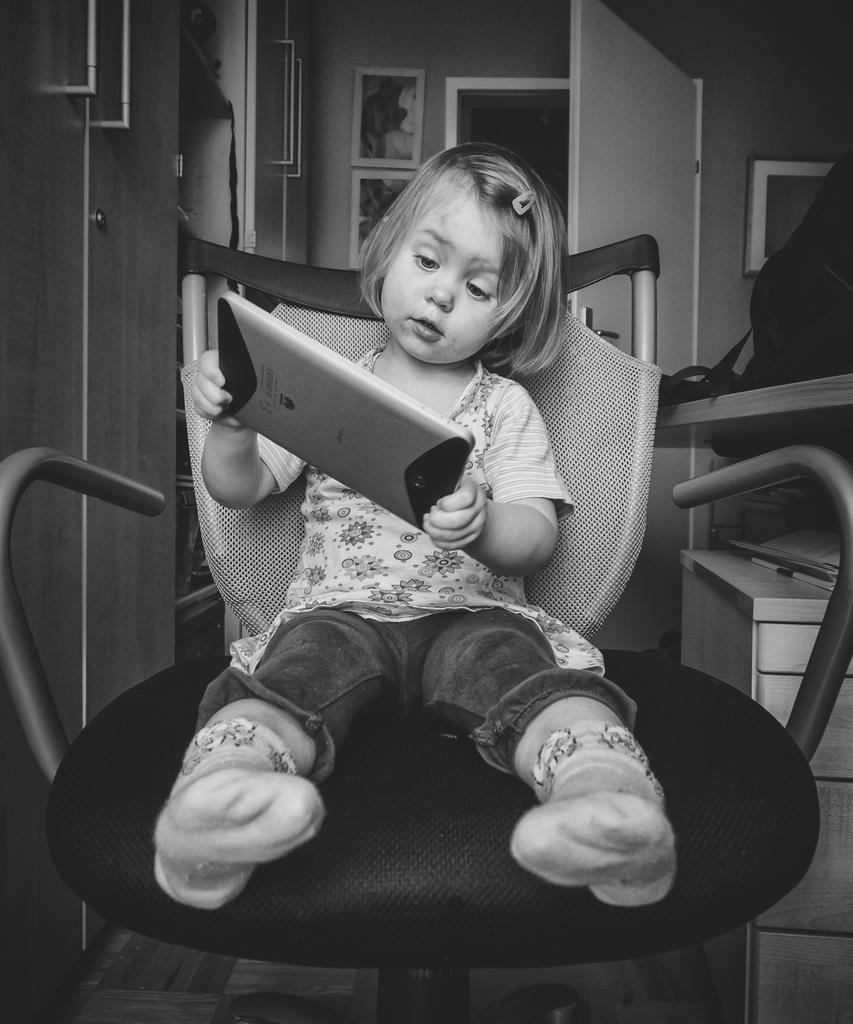Could you give a brief overview of what you see in this image? In this picture I can see there is a girl sitting on the chair and she is holding a smart phone and she is looking into it. She is wearing a shirt, jeans and socks. There is a clip in her hair and there is a cupboard into left and it has handles and there are few photo frames placed on the wall. There is a door and a wooden table at right and there is a bag placed on the table. 